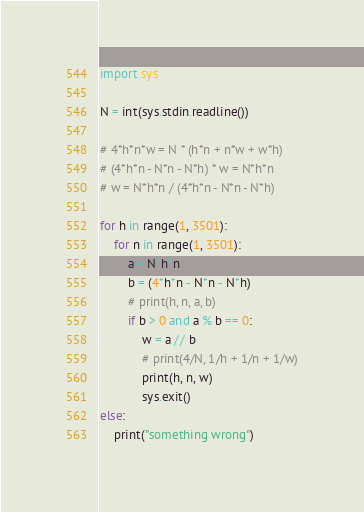Convert code to text. <code><loc_0><loc_0><loc_500><loc_500><_Python_>import sys

N = int(sys.stdin.readline())

# 4*h*n*w = N * (h*n + n*w + w*h)
# (4*h*n - N*n - N*h) * w = N*h*n
# w = N*h*n / (4*h*n - N*n - N*h)

for h in range(1, 3501):
    for n in range(1, 3501):
        a = N*h*n
        b = (4*h*n - N*n - N*h) 
        # print(h, n, a, b)
        if b > 0 and a % b == 0:
            w = a // b
            # print(4/N, 1/h + 1/n + 1/w)
            print(h, n, w)
            sys.exit()
else:
    print("something wrong")</code> 